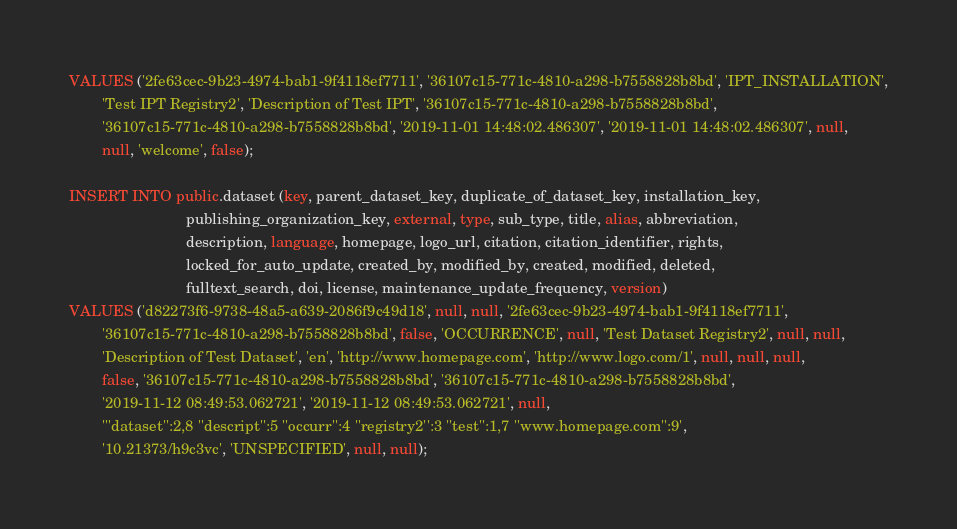<code> <loc_0><loc_0><loc_500><loc_500><_SQL_>VALUES ('2fe63cec-9b23-4974-bab1-9f4118ef7711', '36107c15-771c-4810-a298-b7558828b8bd', 'IPT_INSTALLATION',
        'Test IPT Registry2', 'Description of Test IPT', '36107c15-771c-4810-a298-b7558828b8bd',
        '36107c15-771c-4810-a298-b7558828b8bd', '2019-11-01 14:48:02.486307', '2019-11-01 14:48:02.486307', null,
        null, 'welcome', false);

INSERT INTO public.dataset (key, parent_dataset_key, duplicate_of_dataset_key, installation_key,
                            publishing_organization_key, external, type, sub_type, title, alias, abbreviation,
                            description, language, homepage, logo_url, citation, citation_identifier, rights,
                            locked_for_auto_update, created_by, modified_by, created, modified, deleted,
                            fulltext_search, doi, license, maintenance_update_frequency, version)
VALUES ('d82273f6-9738-48a5-a639-2086f9c49d18', null, null, '2fe63cec-9b23-4974-bab1-9f4118ef7711',
        '36107c15-771c-4810-a298-b7558828b8bd', false, 'OCCURRENCE', null, 'Test Dataset Registry2', null, null,
        'Description of Test Dataset', 'en', 'http://www.homepage.com', 'http://www.logo.com/1', null, null, null,
        false, '36107c15-771c-4810-a298-b7558828b8bd', '36107c15-771c-4810-a298-b7558828b8bd',
        '2019-11-12 08:49:53.062721', '2019-11-12 08:49:53.062721', null,
        '''dataset'':2,8 ''descript'':5 ''occurr'':4 ''registry2'':3 ''test'':1,7 ''www.homepage.com'':9',
        '10.21373/h9c3vc', 'UNSPECIFIED', null, null);
</code> 